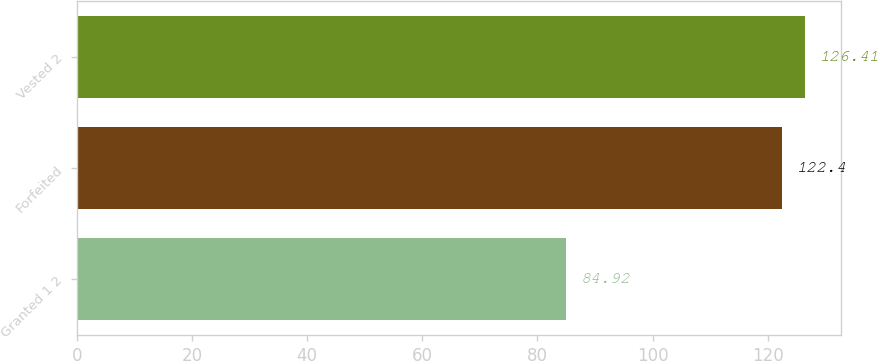Convert chart to OTSL. <chart><loc_0><loc_0><loc_500><loc_500><bar_chart><fcel>Granted 1 2<fcel>Forfeited<fcel>Vested 2<nl><fcel>84.92<fcel>122.4<fcel>126.41<nl></chart> 